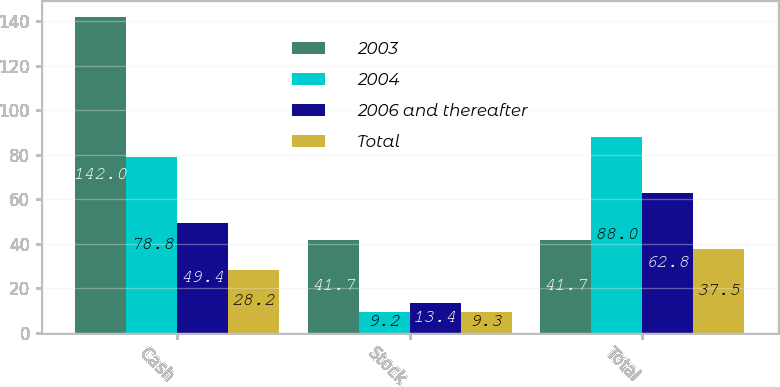Convert chart. <chart><loc_0><loc_0><loc_500><loc_500><stacked_bar_chart><ecel><fcel>Cash<fcel>Stock<fcel>Total<nl><fcel>2003<fcel>142<fcel>41.7<fcel>41.7<nl><fcel>2004<fcel>78.8<fcel>9.2<fcel>88<nl><fcel>2006 and thereafter<fcel>49.4<fcel>13.4<fcel>62.8<nl><fcel>Total<fcel>28.2<fcel>9.3<fcel>37.5<nl></chart> 